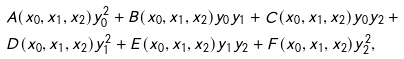Convert formula to latex. <formula><loc_0><loc_0><loc_500><loc_500>& A ( x _ { 0 } , x _ { 1 } , x _ { 2 } ) y _ { 0 } ^ { 2 } + B ( x _ { 0 } , x _ { 1 } , x _ { 2 } ) y _ { 0 } y _ { 1 } + C ( x _ { 0 } , x _ { 1 } , x _ { 2 } ) y _ { 0 } y _ { 2 } \, + \\ & D ( x _ { 0 } , x _ { 1 } , x _ { 2 } ) y _ { 1 } ^ { 2 } + E ( x _ { 0 } , x _ { 1 } , x _ { 2 } ) y _ { 1 } y _ { 2 } + F ( x _ { 0 } , x _ { 1 } , x _ { 2 } ) y _ { 2 } ^ { 2 } ,</formula> 